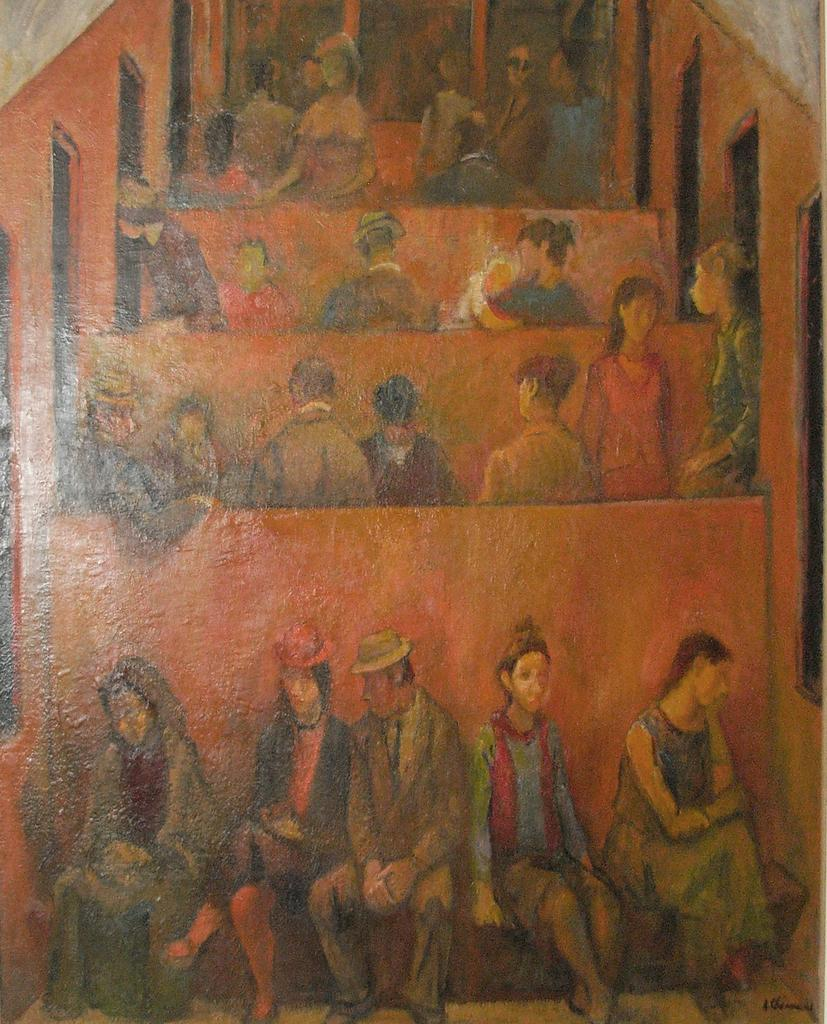What is the main subject of the image? There is a painting in the image. Where is the painting located? The painting is on a wall. What is happening in the painting? The painting depicts some persons sitting. How many laborers are working in the hall depicted in the painting? There is no mention of laborers or a hall in the image; the painting only depicts persons sitting. 